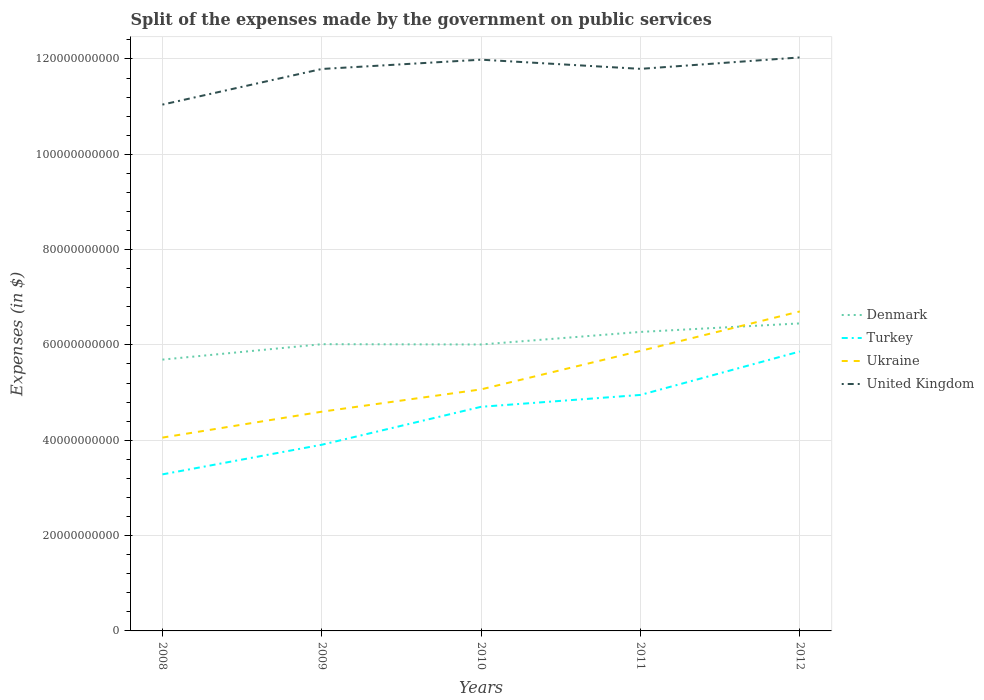Does the line corresponding to Denmark intersect with the line corresponding to Turkey?
Give a very brief answer. No. Is the number of lines equal to the number of legend labels?
Give a very brief answer. Yes. Across all years, what is the maximum expenses made by the government on public services in Ukraine?
Ensure brevity in your answer.  4.06e+1. What is the total expenses made by the government on public services in Ukraine in the graph?
Provide a short and direct response. -8.07e+09. What is the difference between the highest and the second highest expenses made by the government on public services in Denmark?
Offer a terse response. 7.60e+09. What is the difference between the highest and the lowest expenses made by the government on public services in Denmark?
Make the answer very short. 2. How many years are there in the graph?
Your response must be concise. 5. What is the difference between two consecutive major ticks on the Y-axis?
Your answer should be compact. 2.00e+1. Where does the legend appear in the graph?
Give a very brief answer. Center right. How many legend labels are there?
Your answer should be compact. 4. How are the legend labels stacked?
Give a very brief answer. Vertical. What is the title of the graph?
Keep it short and to the point. Split of the expenses made by the government on public services. What is the label or title of the Y-axis?
Offer a terse response. Expenses (in $). What is the Expenses (in $) of Denmark in 2008?
Your answer should be compact. 5.69e+1. What is the Expenses (in $) in Turkey in 2008?
Your answer should be very brief. 3.28e+1. What is the Expenses (in $) of Ukraine in 2008?
Your answer should be compact. 4.06e+1. What is the Expenses (in $) of United Kingdom in 2008?
Your answer should be very brief. 1.10e+11. What is the Expenses (in $) in Denmark in 2009?
Your answer should be very brief. 6.02e+1. What is the Expenses (in $) of Turkey in 2009?
Make the answer very short. 3.91e+1. What is the Expenses (in $) of Ukraine in 2009?
Your answer should be very brief. 4.60e+1. What is the Expenses (in $) of United Kingdom in 2009?
Provide a succinct answer. 1.18e+11. What is the Expenses (in $) of Denmark in 2010?
Give a very brief answer. 6.01e+1. What is the Expenses (in $) of Turkey in 2010?
Your response must be concise. 4.70e+1. What is the Expenses (in $) in Ukraine in 2010?
Give a very brief answer. 5.07e+1. What is the Expenses (in $) in United Kingdom in 2010?
Keep it short and to the point. 1.20e+11. What is the Expenses (in $) of Denmark in 2011?
Make the answer very short. 6.27e+1. What is the Expenses (in $) in Turkey in 2011?
Your answer should be very brief. 4.95e+1. What is the Expenses (in $) of Ukraine in 2011?
Your answer should be very brief. 5.87e+1. What is the Expenses (in $) in United Kingdom in 2011?
Provide a succinct answer. 1.18e+11. What is the Expenses (in $) in Denmark in 2012?
Keep it short and to the point. 6.45e+1. What is the Expenses (in $) in Turkey in 2012?
Offer a very short reply. 5.86e+1. What is the Expenses (in $) of Ukraine in 2012?
Offer a terse response. 6.70e+1. What is the Expenses (in $) of United Kingdom in 2012?
Provide a short and direct response. 1.20e+11. Across all years, what is the maximum Expenses (in $) in Denmark?
Keep it short and to the point. 6.45e+1. Across all years, what is the maximum Expenses (in $) of Turkey?
Give a very brief answer. 5.86e+1. Across all years, what is the maximum Expenses (in $) in Ukraine?
Your answer should be very brief. 6.70e+1. Across all years, what is the maximum Expenses (in $) in United Kingdom?
Ensure brevity in your answer.  1.20e+11. Across all years, what is the minimum Expenses (in $) of Denmark?
Provide a short and direct response. 5.69e+1. Across all years, what is the minimum Expenses (in $) of Turkey?
Provide a succinct answer. 3.28e+1. Across all years, what is the minimum Expenses (in $) in Ukraine?
Make the answer very short. 4.06e+1. Across all years, what is the minimum Expenses (in $) of United Kingdom?
Give a very brief answer. 1.10e+11. What is the total Expenses (in $) of Denmark in the graph?
Offer a terse response. 3.04e+11. What is the total Expenses (in $) of Turkey in the graph?
Offer a very short reply. 2.27e+11. What is the total Expenses (in $) of Ukraine in the graph?
Provide a succinct answer. 2.63e+11. What is the total Expenses (in $) in United Kingdom in the graph?
Provide a succinct answer. 5.86e+11. What is the difference between the Expenses (in $) in Denmark in 2008 and that in 2009?
Offer a very short reply. -3.23e+09. What is the difference between the Expenses (in $) in Turkey in 2008 and that in 2009?
Provide a short and direct response. -6.22e+09. What is the difference between the Expenses (in $) in Ukraine in 2008 and that in 2009?
Your response must be concise. -5.44e+09. What is the difference between the Expenses (in $) in United Kingdom in 2008 and that in 2009?
Make the answer very short. -7.48e+09. What is the difference between the Expenses (in $) of Denmark in 2008 and that in 2010?
Your response must be concise. -3.17e+09. What is the difference between the Expenses (in $) of Turkey in 2008 and that in 2010?
Make the answer very short. -1.42e+1. What is the difference between the Expenses (in $) of Ukraine in 2008 and that in 2010?
Offer a very short reply. -1.01e+1. What is the difference between the Expenses (in $) of United Kingdom in 2008 and that in 2010?
Keep it short and to the point. -9.43e+09. What is the difference between the Expenses (in $) in Denmark in 2008 and that in 2011?
Make the answer very short. -5.81e+09. What is the difference between the Expenses (in $) in Turkey in 2008 and that in 2011?
Ensure brevity in your answer.  -1.67e+1. What is the difference between the Expenses (in $) of Ukraine in 2008 and that in 2011?
Ensure brevity in your answer.  -1.82e+1. What is the difference between the Expenses (in $) in United Kingdom in 2008 and that in 2011?
Offer a very short reply. -7.50e+09. What is the difference between the Expenses (in $) in Denmark in 2008 and that in 2012?
Offer a terse response. -7.60e+09. What is the difference between the Expenses (in $) in Turkey in 2008 and that in 2012?
Provide a short and direct response. -2.58e+1. What is the difference between the Expenses (in $) of Ukraine in 2008 and that in 2012?
Make the answer very short. -2.65e+1. What is the difference between the Expenses (in $) in United Kingdom in 2008 and that in 2012?
Your answer should be compact. -9.90e+09. What is the difference between the Expenses (in $) in Denmark in 2009 and that in 2010?
Make the answer very short. 6.10e+07. What is the difference between the Expenses (in $) of Turkey in 2009 and that in 2010?
Provide a succinct answer. -7.96e+09. What is the difference between the Expenses (in $) of Ukraine in 2009 and that in 2010?
Keep it short and to the point. -4.68e+09. What is the difference between the Expenses (in $) of United Kingdom in 2009 and that in 2010?
Ensure brevity in your answer.  -1.95e+09. What is the difference between the Expenses (in $) of Denmark in 2009 and that in 2011?
Your response must be concise. -2.58e+09. What is the difference between the Expenses (in $) in Turkey in 2009 and that in 2011?
Make the answer very short. -1.05e+1. What is the difference between the Expenses (in $) in Ukraine in 2009 and that in 2011?
Give a very brief answer. -1.28e+1. What is the difference between the Expenses (in $) of United Kingdom in 2009 and that in 2011?
Give a very brief answer. -2.40e+07. What is the difference between the Expenses (in $) in Denmark in 2009 and that in 2012?
Provide a short and direct response. -4.36e+09. What is the difference between the Expenses (in $) in Turkey in 2009 and that in 2012?
Offer a very short reply. -1.96e+1. What is the difference between the Expenses (in $) of Ukraine in 2009 and that in 2012?
Give a very brief answer. -2.10e+1. What is the difference between the Expenses (in $) in United Kingdom in 2009 and that in 2012?
Keep it short and to the point. -2.42e+09. What is the difference between the Expenses (in $) in Denmark in 2010 and that in 2011?
Ensure brevity in your answer.  -2.64e+09. What is the difference between the Expenses (in $) of Turkey in 2010 and that in 2011?
Your answer should be very brief. -2.49e+09. What is the difference between the Expenses (in $) of Ukraine in 2010 and that in 2011?
Your answer should be very brief. -8.07e+09. What is the difference between the Expenses (in $) of United Kingdom in 2010 and that in 2011?
Offer a very short reply. 1.92e+09. What is the difference between the Expenses (in $) in Denmark in 2010 and that in 2012?
Make the answer very short. -4.42e+09. What is the difference between the Expenses (in $) in Turkey in 2010 and that in 2012?
Ensure brevity in your answer.  -1.16e+1. What is the difference between the Expenses (in $) of Ukraine in 2010 and that in 2012?
Offer a very short reply. -1.63e+1. What is the difference between the Expenses (in $) in United Kingdom in 2010 and that in 2012?
Provide a succinct answer. -4.76e+08. What is the difference between the Expenses (in $) of Denmark in 2011 and that in 2012?
Your response must be concise. -1.79e+09. What is the difference between the Expenses (in $) of Turkey in 2011 and that in 2012?
Give a very brief answer. -9.12e+09. What is the difference between the Expenses (in $) of Ukraine in 2011 and that in 2012?
Keep it short and to the point. -8.28e+09. What is the difference between the Expenses (in $) in United Kingdom in 2011 and that in 2012?
Offer a terse response. -2.40e+09. What is the difference between the Expenses (in $) in Denmark in 2008 and the Expenses (in $) in Turkey in 2009?
Provide a short and direct response. 1.79e+1. What is the difference between the Expenses (in $) of Denmark in 2008 and the Expenses (in $) of Ukraine in 2009?
Keep it short and to the point. 1.09e+1. What is the difference between the Expenses (in $) in Denmark in 2008 and the Expenses (in $) in United Kingdom in 2009?
Your answer should be very brief. -6.10e+1. What is the difference between the Expenses (in $) of Turkey in 2008 and the Expenses (in $) of Ukraine in 2009?
Ensure brevity in your answer.  -1.32e+1. What is the difference between the Expenses (in $) in Turkey in 2008 and the Expenses (in $) in United Kingdom in 2009?
Your response must be concise. -8.51e+1. What is the difference between the Expenses (in $) of Ukraine in 2008 and the Expenses (in $) of United Kingdom in 2009?
Your response must be concise. -7.73e+1. What is the difference between the Expenses (in $) in Denmark in 2008 and the Expenses (in $) in Turkey in 2010?
Your response must be concise. 9.90e+09. What is the difference between the Expenses (in $) in Denmark in 2008 and the Expenses (in $) in Ukraine in 2010?
Give a very brief answer. 6.24e+09. What is the difference between the Expenses (in $) of Denmark in 2008 and the Expenses (in $) of United Kingdom in 2010?
Offer a terse response. -6.29e+1. What is the difference between the Expenses (in $) in Turkey in 2008 and the Expenses (in $) in Ukraine in 2010?
Your answer should be very brief. -1.78e+1. What is the difference between the Expenses (in $) in Turkey in 2008 and the Expenses (in $) in United Kingdom in 2010?
Keep it short and to the point. -8.70e+1. What is the difference between the Expenses (in $) in Ukraine in 2008 and the Expenses (in $) in United Kingdom in 2010?
Ensure brevity in your answer.  -7.93e+1. What is the difference between the Expenses (in $) of Denmark in 2008 and the Expenses (in $) of Turkey in 2011?
Ensure brevity in your answer.  7.41e+09. What is the difference between the Expenses (in $) in Denmark in 2008 and the Expenses (in $) in Ukraine in 2011?
Offer a terse response. -1.83e+09. What is the difference between the Expenses (in $) in Denmark in 2008 and the Expenses (in $) in United Kingdom in 2011?
Offer a very short reply. -6.10e+1. What is the difference between the Expenses (in $) in Turkey in 2008 and the Expenses (in $) in Ukraine in 2011?
Your answer should be compact. -2.59e+1. What is the difference between the Expenses (in $) of Turkey in 2008 and the Expenses (in $) of United Kingdom in 2011?
Your answer should be compact. -8.51e+1. What is the difference between the Expenses (in $) in Ukraine in 2008 and the Expenses (in $) in United Kingdom in 2011?
Your answer should be compact. -7.74e+1. What is the difference between the Expenses (in $) in Denmark in 2008 and the Expenses (in $) in Turkey in 2012?
Provide a short and direct response. -1.71e+09. What is the difference between the Expenses (in $) in Denmark in 2008 and the Expenses (in $) in Ukraine in 2012?
Your answer should be compact. -1.01e+1. What is the difference between the Expenses (in $) of Denmark in 2008 and the Expenses (in $) of United Kingdom in 2012?
Your answer should be very brief. -6.34e+1. What is the difference between the Expenses (in $) in Turkey in 2008 and the Expenses (in $) in Ukraine in 2012?
Ensure brevity in your answer.  -3.42e+1. What is the difference between the Expenses (in $) in Turkey in 2008 and the Expenses (in $) in United Kingdom in 2012?
Offer a terse response. -8.75e+1. What is the difference between the Expenses (in $) of Ukraine in 2008 and the Expenses (in $) of United Kingdom in 2012?
Your response must be concise. -7.98e+1. What is the difference between the Expenses (in $) in Denmark in 2009 and the Expenses (in $) in Turkey in 2010?
Give a very brief answer. 1.31e+1. What is the difference between the Expenses (in $) of Denmark in 2009 and the Expenses (in $) of Ukraine in 2010?
Offer a terse response. 9.48e+09. What is the difference between the Expenses (in $) in Denmark in 2009 and the Expenses (in $) in United Kingdom in 2010?
Your answer should be compact. -5.97e+1. What is the difference between the Expenses (in $) in Turkey in 2009 and the Expenses (in $) in Ukraine in 2010?
Your answer should be compact. -1.16e+1. What is the difference between the Expenses (in $) of Turkey in 2009 and the Expenses (in $) of United Kingdom in 2010?
Give a very brief answer. -8.08e+1. What is the difference between the Expenses (in $) of Ukraine in 2009 and the Expenses (in $) of United Kingdom in 2010?
Offer a very short reply. -7.38e+1. What is the difference between the Expenses (in $) in Denmark in 2009 and the Expenses (in $) in Turkey in 2011?
Your answer should be very brief. 1.06e+1. What is the difference between the Expenses (in $) in Denmark in 2009 and the Expenses (in $) in Ukraine in 2011?
Your answer should be very brief. 1.41e+09. What is the difference between the Expenses (in $) of Denmark in 2009 and the Expenses (in $) of United Kingdom in 2011?
Your answer should be compact. -5.78e+1. What is the difference between the Expenses (in $) in Turkey in 2009 and the Expenses (in $) in Ukraine in 2011?
Provide a succinct answer. -1.97e+1. What is the difference between the Expenses (in $) of Turkey in 2009 and the Expenses (in $) of United Kingdom in 2011?
Ensure brevity in your answer.  -7.89e+1. What is the difference between the Expenses (in $) in Ukraine in 2009 and the Expenses (in $) in United Kingdom in 2011?
Your answer should be compact. -7.19e+1. What is the difference between the Expenses (in $) of Denmark in 2009 and the Expenses (in $) of Turkey in 2012?
Your response must be concise. 1.53e+09. What is the difference between the Expenses (in $) of Denmark in 2009 and the Expenses (in $) of Ukraine in 2012?
Give a very brief answer. -6.87e+09. What is the difference between the Expenses (in $) in Denmark in 2009 and the Expenses (in $) in United Kingdom in 2012?
Offer a very short reply. -6.02e+1. What is the difference between the Expenses (in $) of Turkey in 2009 and the Expenses (in $) of Ukraine in 2012?
Your response must be concise. -2.80e+1. What is the difference between the Expenses (in $) in Turkey in 2009 and the Expenses (in $) in United Kingdom in 2012?
Ensure brevity in your answer.  -8.13e+1. What is the difference between the Expenses (in $) of Ukraine in 2009 and the Expenses (in $) of United Kingdom in 2012?
Offer a terse response. -7.43e+1. What is the difference between the Expenses (in $) of Denmark in 2010 and the Expenses (in $) of Turkey in 2011?
Offer a terse response. 1.06e+1. What is the difference between the Expenses (in $) in Denmark in 2010 and the Expenses (in $) in Ukraine in 2011?
Ensure brevity in your answer.  1.34e+09. What is the difference between the Expenses (in $) in Denmark in 2010 and the Expenses (in $) in United Kingdom in 2011?
Your answer should be compact. -5.78e+1. What is the difference between the Expenses (in $) in Turkey in 2010 and the Expenses (in $) in Ukraine in 2011?
Ensure brevity in your answer.  -1.17e+1. What is the difference between the Expenses (in $) of Turkey in 2010 and the Expenses (in $) of United Kingdom in 2011?
Give a very brief answer. -7.09e+1. What is the difference between the Expenses (in $) of Ukraine in 2010 and the Expenses (in $) of United Kingdom in 2011?
Offer a very short reply. -6.72e+1. What is the difference between the Expenses (in $) in Denmark in 2010 and the Expenses (in $) in Turkey in 2012?
Provide a short and direct response. 1.47e+09. What is the difference between the Expenses (in $) in Denmark in 2010 and the Expenses (in $) in Ukraine in 2012?
Offer a terse response. -6.93e+09. What is the difference between the Expenses (in $) of Denmark in 2010 and the Expenses (in $) of United Kingdom in 2012?
Your answer should be compact. -6.02e+1. What is the difference between the Expenses (in $) of Turkey in 2010 and the Expenses (in $) of Ukraine in 2012?
Offer a very short reply. -2.00e+1. What is the difference between the Expenses (in $) of Turkey in 2010 and the Expenses (in $) of United Kingdom in 2012?
Offer a terse response. -7.33e+1. What is the difference between the Expenses (in $) of Ukraine in 2010 and the Expenses (in $) of United Kingdom in 2012?
Your answer should be very brief. -6.96e+1. What is the difference between the Expenses (in $) in Denmark in 2011 and the Expenses (in $) in Turkey in 2012?
Offer a terse response. 4.10e+09. What is the difference between the Expenses (in $) in Denmark in 2011 and the Expenses (in $) in Ukraine in 2012?
Keep it short and to the point. -4.30e+09. What is the difference between the Expenses (in $) of Denmark in 2011 and the Expenses (in $) of United Kingdom in 2012?
Keep it short and to the point. -5.76e+1. What is the difference between the Expenses (in $) in Turkey in 2011 and the Expenses (in $) in Ukraine in 2012?
Offer a very short reply. -1.75e+1. What is the difference between the Expenses (in $) in Turkey in 2011 and the Expenses (in $) in United Kingdom in 2012?
Make the answer very short. -7.08e+1. What is the difference between the Expenses (in $) in Ukraine in 2011 and the Expenses (in $) in United Kingdom in 2012?
Ensure brevity in your answer.  -6.16e+1. What is the average Expenses (in $) of Denmark per year?
Make the answer very short. 6.09e+1. What is the average Expenses (in $) in Turkey per year?
Make the answer very short. 4.54e+1. What is the average Expenses (in $) of Ukraine per year?
Your answer should be very brief. 5.26e+1. What is the average Expenses (in $) in United Kingdom per year?
Provide a short and direct response. 1.17e+11. In the year 2008, what is the difference between the Expenses (in $) of Denmark and Expenses (in $) of Turkey?
Offer a terse response. 2.41e+1. In the year 2008, what is the difference between the Expenses (in $) of Denmark and Expenses (in $) of Ukraine?
Your response must be concise. 1.64e+1. In the year 2008, what is the difference between the Expenses (in $) in Denmark and Expenses (in $) in United Kingdom?
Offer a very short reply. -5.35e+1. In the year 2008, what is the difference between the Expenses (in $) of Turkey and Expenses (in $) of Ukraine?
Your answer should be very brief. -7.72e+09. In the year 2008, what is the difference between the Expenses (in $) of Turkey and Expenses (in $) of United Kingdom?
Your answer should be very brief. -7.76e+1. In the year 2008, what is the difference between the Expenses (in $) of Ukraine and Expenses (in $) of United Kingdom?
Provide a short and direct response. -6.99e+1. In the year 2009, what is the difference between the Expenses (in $) of Denmark and Expenses (in $) of Turkey?
Your answer should be compact. 2.11e+1. In the year 2009, what is the difference between the Expenses (in $) in Denmark and Expenses (in $) in Ukraine?
Offer a terse response. 1.42e+1. In the year 2009, what is the difference between the Expenses (in $) in Denmark and Expenses (in $) in United Kingdom?
Provide a short and direct response. -5.77e+1. In the year 2009, what is the difference between the Expenses (in $) in Turkey and Expenses (in $) in Ukraine?
Your answer should be very brief. -6.94e+09. In the year 2009, what is the difference between the Expenses (in $) of Turkey and Expenses (in $) of United Kingdom?
Ensure brevity in your answer.  -7.88e+1. In the year 2009, what is the difference between the Expenses (in $) in Ukraine and Expenses (in $) in United Kingdom?
Keep it short and to the point. -7.19e+1. In the year 2010, what is the difference between the Expenses (in $) in Denmark and Expenses (in $) in Turkey?
Give a very brief answer. 1.31e+1. In the year 2010, what is the difference between the Expenses (in $) of Denmark and Expenses (in $) of Ukraine?
Provide a succinct answer. 9.42e+09. In the year 2010, what is the difference between the Expenses (in $) of Denmark and Expenses (in $) of United Kingdom?
Your answer should be compact. -5.97e+1. In the year 2010, what is the difference between the Expenses (in $) of Turkey and Expenses (in $) of Ukraine?
Provide a short and direct response. -3.66e+09. In the year 2010, what is the difference between the Expenses (in $) of Turkey and Expenses (in $) of United Kingdom?
Provide a succinct answer. -7.28e+1. In the year 2010, what is the difference between the Expenses (in $) in Ukraine and Expenses (in $) in United Kingdom?
Your answer should be very brief. -6.92e+1. In the year 2011, what is the difference between the Expenses (in $) in Denmark and Expenses (in $) in Turkey?
Your answer should be compact. 1.32e+1. In the year 2011, what is the difference between the Expenses (in $) in Denmark and Expenses (in $) in Ukraine?
Give a very brief answer. 3.98e+09. In the year 2011, what is the difference between the Expenses (in $) of Denmark and Expenses (in $) of United Kingdom?
Give a very brief answer. -5.52e+1. In the year 2011, what is the difference between the Expenses (in $) of Turkey and Expenses (in $) of Ukraine?
Your response must be concise. -9.24e+09. In the year 2011, what is the difference between the Expenses (in $) in Turkey and Expenses (in $) in United Kingdom?
Provide a succinct answer. -6.84e+1. In the year 2011, what is the difference between the Expenses (in $) in Ukraine and Expenses (in $) in United Kingdom?
Your answer should be compact. -5.92e+1. In the year 2012, what is the difference between the Expenses (in $) in Denmark and Expenses (in $) in Turkey?
Provide a short and direct response. 5.89e+09. In the year 2012, what is the difference between the Expenses (in $) of Denmark and Expenses (in $) of Ukraine?
Offer a very short reply. -2.51e+09. In the year 2012, what is the difference between the Expenses (in $) of Denmark and Expenses (in $) of United Kingdom?
Provide a succinct answer. -5.58e+1. In the year 2012, what is the difference between the Expenses (in $) in Turkey and Expenses (in $) in Ukraine?
Ensure brevity in your answer.  -8.40e+09. In the year 2012, what is the difference between the Expenses (in $) in Turkey and Expenses (in $) in United Kingdom?
Make the answer very short. -6.17e+1. In the year 2012, what is the difference between the Expenses (in $) of Ukraine and Expenses (in $) of United Kingdom?
Give a very brief answer. -5.33e+1. What is the ratio of the Expenses (in $) of Denmark in 2008 to that in 2009?
Offer a terse response. 0.95. What is the ratio of the Expenses (in $) in Turkey in 2008 to that in 2009?
Ensure brevity in your answer.  0.84. What is the ratio of the Expenses (in $) of Ukraine in 2008 to that in 2009?
Your answer should be very brief. 0.88. What is the ratio of the Expenses (in $) in United Kingdom in 2008 to that in 2009?
Your answer should be very brief. 0.94. What is the ratio of the Expenses (in $) of Denmark in 2008 to that in 2010?
Offer a terse response. 0.95. What is the ratio of the Expenses (in $) of Turkey in 2008 to that in 2010?
Your answer should be compact. 0.7. What is the ratio of the Expenses (in $) of Ukraine in 2008 to that in 2010?
Provide a succinct answer. 0.8. What is the ratio of the Expenses (in $) of United Kingdom in 2008 to that in 2010?
Your answer should be very brief. 0.92. What is the ratio of the Expenses (in $) in Denmark in 2008 to that in 2011?
Make the answer very short. 0.91. What is the ratio of the Expenses (in $) of Turkey in 2008 to that in 2011?
Offer a terse response. 0.66. What is the ratio of the Expenses (in $) of Ukraine in 2008 to that in 2011?
Provide a short and direct response. 0.69. What is the ratio of the Expenses (in $) of United Kingdom in 2008 to that in 2011?
Provide a succinct answer. 0.94. What is the ratio of the Expenses (in $) of Denmark in 2008 to that in 2012?
Provide a succinct answer. 0.88. What is the ratio of the Expenses (in $) in Turkey in 2008 to that in 2012?
Make the answer very short. 0.56. What is the ratio of the Expenses (in $) of Ukraine in 2008 to that in 2012?
Your answer should be very brief. 0.61. What is the ratio of the Expenses (in $) in United Kingdom in 2008 to that in 2012?
Ensure brevity in your answer.  0.92. What is the ratio of the Expenses (in $) of Turkey in 2009 to that in 2010?
Make the answer very short. 0.83. What is the ratio of the Expenses (in $) of Ukraine in 2009 to that in 2010?
Your answer should be compact. 0.91. What is the ratio of the Expenses (in $) in United Kingdom in 2009 to that in 2010?
Provide a succinct answer. 0.98. What is the ratio of the Expenses (in $) of Turkey in 2009 to that in 2011?
Give a very brief answer. 0.79. What is the ratio of the Expenses (in $) in Ukraine in 2009 to that in 2011?
Your response must be concise. 0.78. What is the ratio of the Expenses (in $) of Denmark in 2009 to that in 2012?
Offer a very short reply. 0.93. What is the ratio of the Expenses (in $) of Turkey in 2009 to that in 2012?
Offer a very short reply. 0.67. What is the ratio of the Expenses (in $) in Ukraine in 2009 to that in 2012?
Provide a succinct answer. 0.69. What is the ratio of the Expenses (in $) in United Kingdom in 2009 to that in 2012?
Your answer should be very brief. 0.98. What is the ratio of the Expenses (in $) in Denmark in 2010 to that in 2011?
Provide a succinct answer. 0.96. What is the ratio of the Expenses (in $) of Turkey in 2010 to that in 2011?
Offer a very short reply. 0.95. What is the ratio of the Expenses (in $) of Ukraine in 2010 to that in 2011?
Your answer should be compact. 0.86. What is the ratio of the Expenses (in $) of United Kingdom in 2010 to that in 2011?
Your answer should be very brief. 1.02. What is the ratio of the Expenses (in $) of Denmark in 2010 to that in 2012?
Your answer should be very brief. 0.93. What is the ratio of the Expenses (in $) in Turkey in 2010 to that in 2012?
Give a very brief answer. 0.8. What is the ratio of the Expenses (in $) of Ukraine in 2010 to that in 2012?
Provide a short and direct response. 0.76. What is the ratio of the Expenses (in $) of Denmark in 2011 to that in 2012?
Offer a very short reply. 0.97. What is the ratio of the Expenses (in $) in Turkey in 2011 to that in 2012?
Your answer should be very brief. 0.84. What is the ratio of the Expenses (in $) in Ukraine in 2011 to that in 2012?
Ensure brevity in your answer.  0.88. What is the ratio of the Expenses (in $) in United Kingdom in 2011 to that in 2012?
Your response must be concise. 0.98. What is the difference between the highest and the second highest Expenses (in $) in Denmark?
Ensure brevity in your answer.  1.79e+09. What is the difference between the highest and the second highest Expenses (in $) of Turkey?
Provide a short and direct response. 9.12e+09. What is the difference between the highest and the second highest Expenses (in $) in Ukraine?
Give a very brief answer. 8.28e+09. What is the difference between the highest and the second highest Expenses (in $) in United Kingdom?
Make the answer very short. 4.76e+08. What is the difference between the highest and the lowest Expenses (in $) of Denmark?
Give a very brief answer. 7.60e+09. What is the difference between the highest and the lowest Expenses (in $) of Turkey?
Ensure brevity in your answer.  2.58e+1. What is the difference between the highest and the lowest Expenses (in $) of Ukraine?
Provide a short and direct response. 2.65e+1. What is the difference between the highest and the lowest Expenses (in $) of United Kingdom?
Your answer should be very brief. 9.90e+09. 